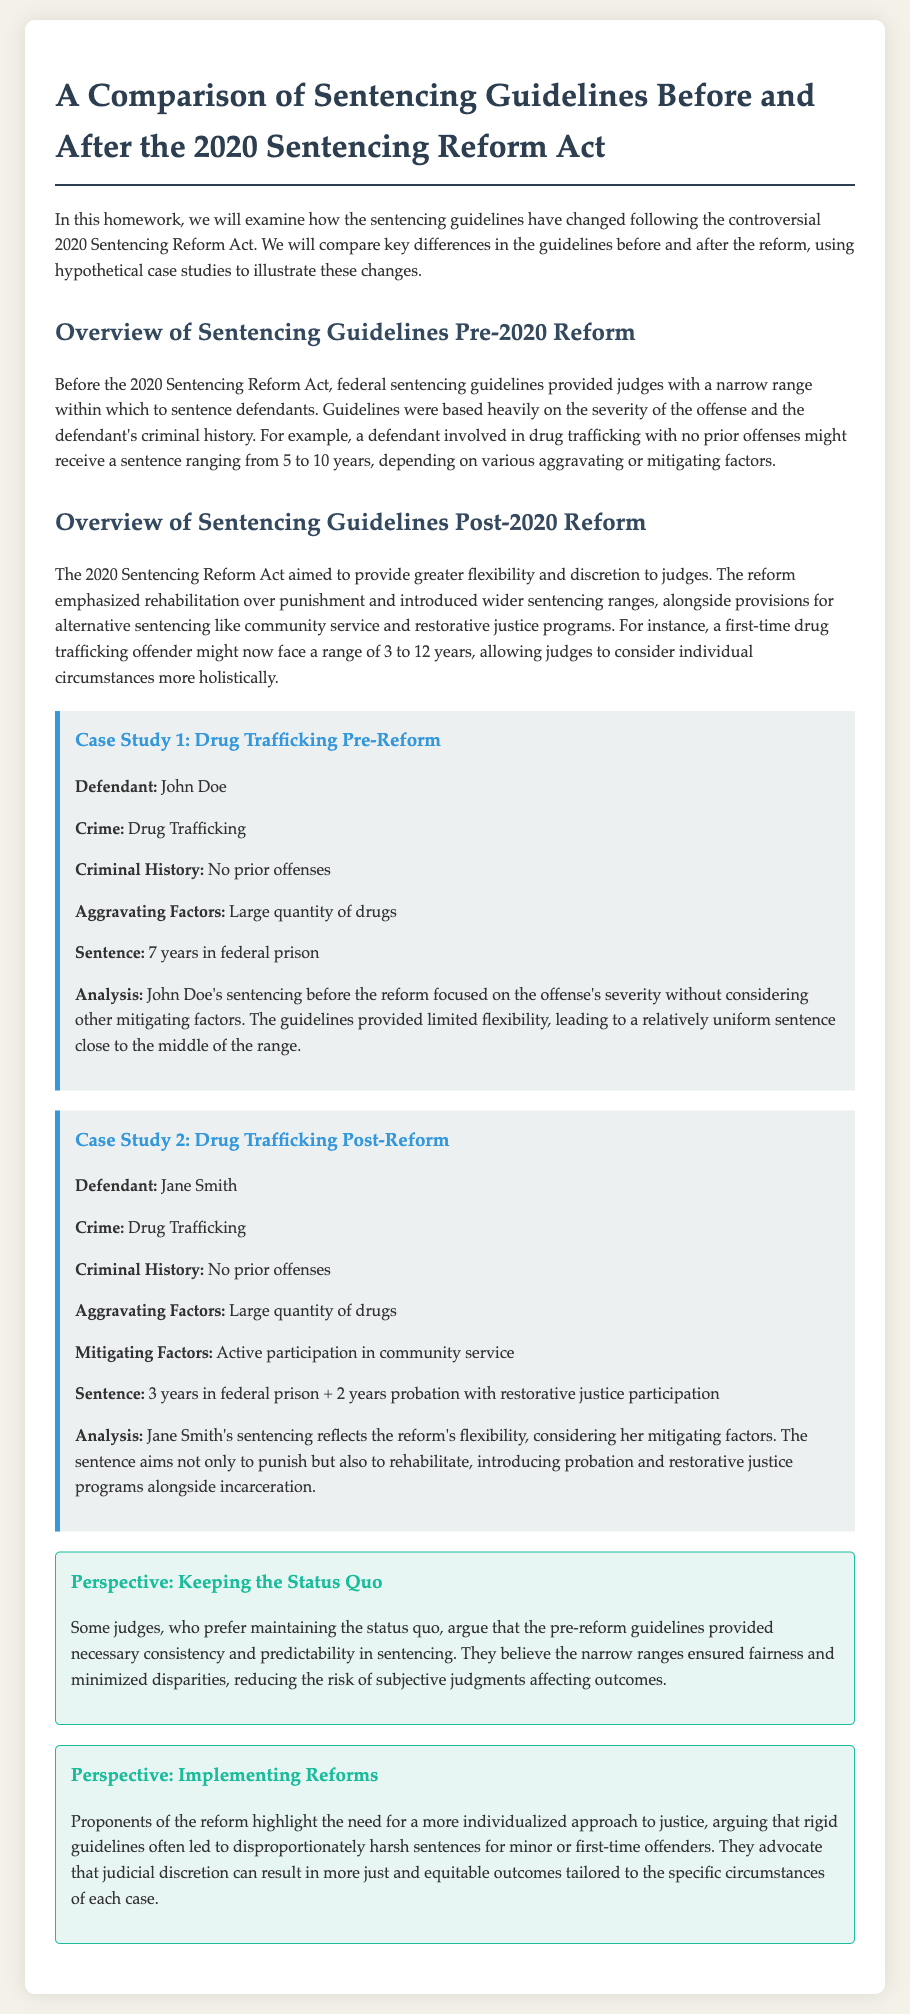What did the 2020 Sentencing Reform Act emphasize? The reform aimed to provide greater flexibility and discretion to judges, emphasizing rehabilitation over punishment.
Answer: rehabilitation What was John Doe's sentence? John Doe received a sentence of 7 years in federal prison for drug trafficking before the reform.
Answer: 7 years What factors were considered in Jane Smith's sentencing? Jane Smith's sentencing considered both aggravating factors (large quantity of drugs) and mitigating factors (active participation in community service).
Answer: aggravating and mitigating factors What is one argument for maintaining the status quo? Some judges argue the pre-reform guidelines provided necessary consistency and predictability in sentencing.
Answer: consistency What is a consequence highlighted by proponents of the reform? Proponents of the reform argue that rigid guidelines often led to disproportionately harsh sentences for minor or first-time offenders.
Answer: disproportionately harsh sentences 